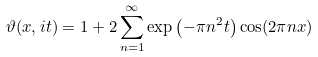Convert formula to latex. <formula><loc_0><loc_0><loc_500><loc_500>\vartheta ( x , i t ) = 1 + 2 \sum _ { n = 1 } ^ { \infty } \exp \left ( - \pi n ^ { 2 } t \right ) \cos ( 2 \pi n x )</formula> 